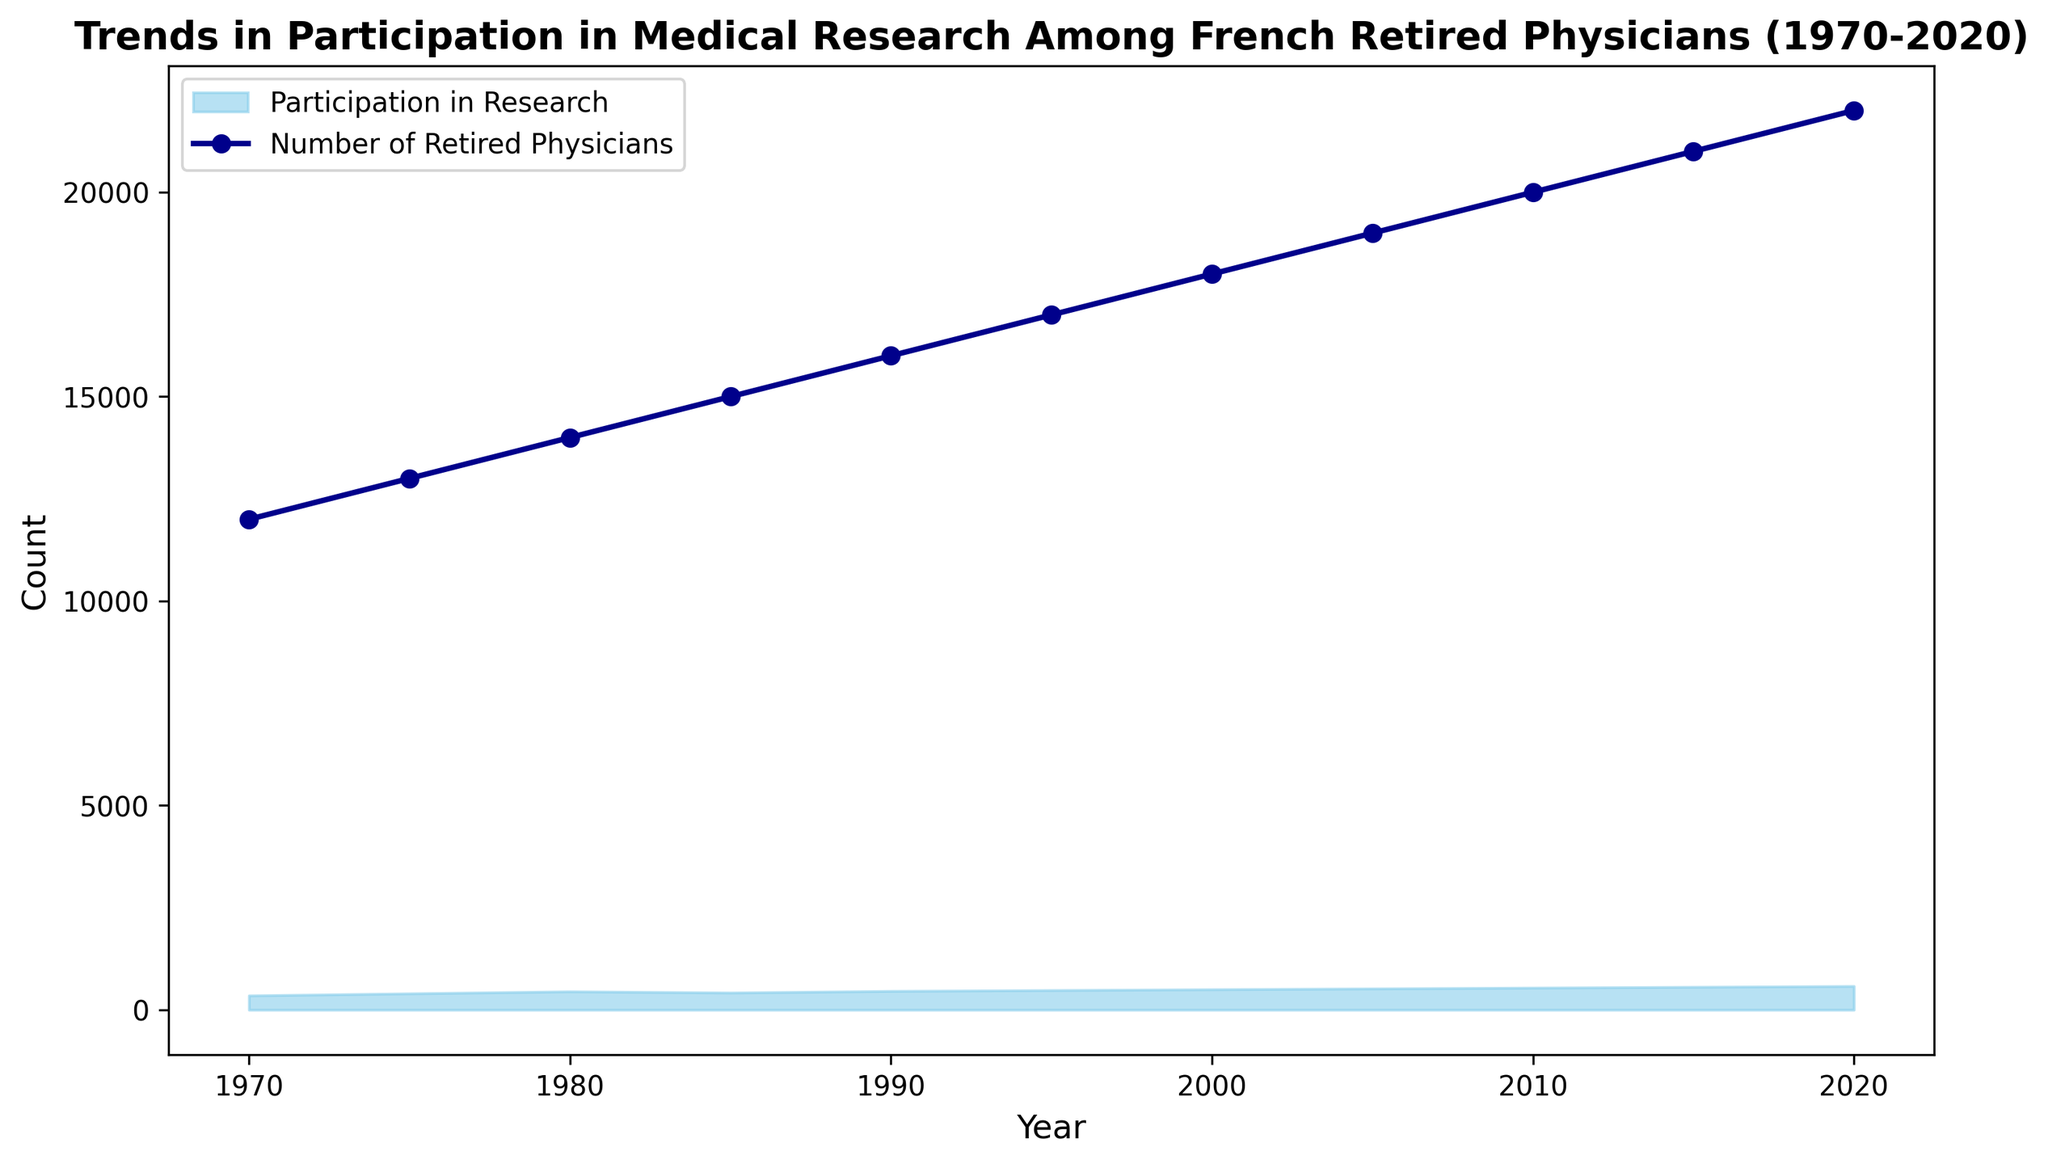What is the general trend of the number of retired physicians from 1970 to 2020? Over the years from 1970 to 2020, the line representing the number of retired physicians steadily increases, indicating a rising trend in the number of retired physicians.
Answer: Increasing How many retired physicians were there in 2000, and what was the participation in research that year? To answer this, find the data points for the year 2000 on the graph. The plot shows 18,000 retired physicians and 500 participations in research.
Answer: 18,000 retired physicians and 500 participation in research Compare the number of retired physicians in 1970 and 2020. Which year had more? The data shows 12,000 retired physicians in 1970 and 22,000 in 2020. Therefore, 2020 had more retired physicians compared to 1970.
Answer: 2020 What is the average participation in research over the 50 years period from 1970 to 2020? To compute the average, sum all participation values and divide by the number of years. The sum is (350 + 400 + 450 + 420 + 460 + 480 + 500 + 520 + 540 + 560 + 580) = 5260. Dividing by 11 (number of data points), the average participation is approximately 478.18.
Answer: 478.18 In which year did the participation in medical research see a decline compared to the previous period? Comparing adjoining years shows that participation in research declined from 450 in 1980 to 420 in 1985. Hence, the decline happened in 1985 compared to 1980.
Answer: 1985 What is the difference in the number of retired physicians between 1995 and 2015? Subtract the number of retired physicians in 1995 from that in 2015. The difference is 21,000 - 17,000 = 4,000.
Answer: 4,000 How does the color intensity of the area chart representing participation in research change over the years? The area representing participation in research is filled with a sky blue color which maintains consistent intensity throughout the chart but gradually increases in height, showing more participation over the years.
Answer: Consistent color but increasing height Which year has the highest number of participations in research? From the figure, the highest participation (580) can be observed in the year 2020.
Answer: 2020 By what percentage did the number of retired physicians increase from 1970 to 2020? Calculate the increase from 1970 (12,000) to 2020 (22,000). The increase is 22,000 - 12,000 = 10,000. To find the percentage increase: (10,000 / 12,000) * 100 ≈ 83.33%.
Answer: 83.33% What is the difference in participation in medical research between the years 1990 and 2010? Subtract the participation value in 1990 from that in 2010. The difference is 540 - 460 = 80.
Answer: 80 